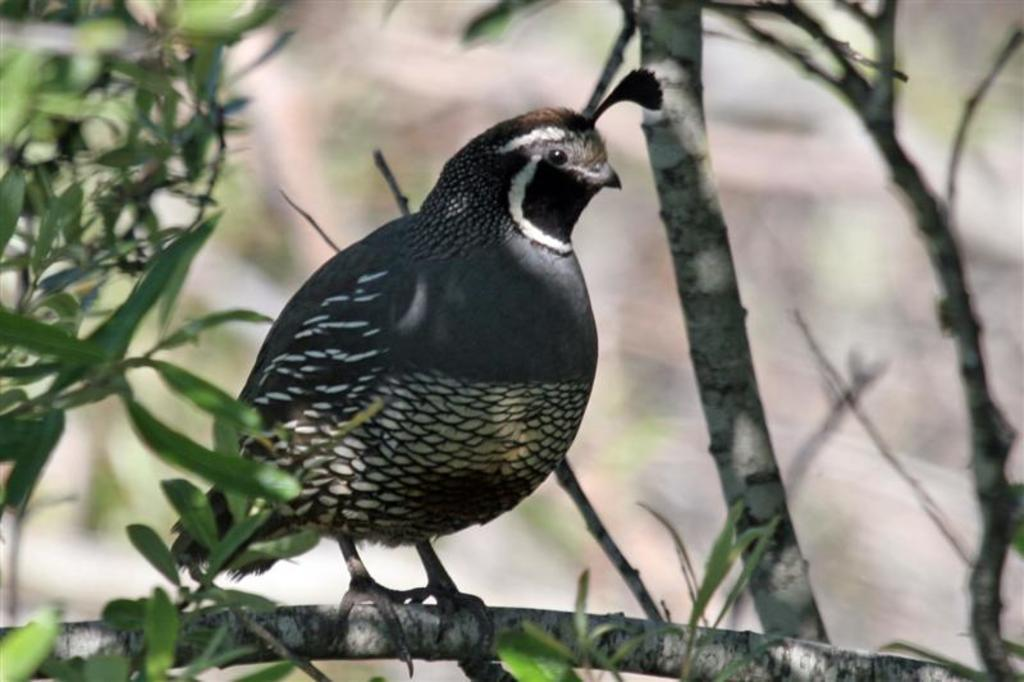What type of animal can be seen in the image? There is a bird in the image. Where is the bird located? The bird is standing on a tree branch. What type of vegetation is present in the image? There are green leaves visible in the image. How would you describe the background of the image? The background of the image appears blurry. What is the bird's opinion on the current state of society in the image? The image does not provide any information about the bird's opinion on society, as it is focused on the bird's physical location and the surrounding environment. 